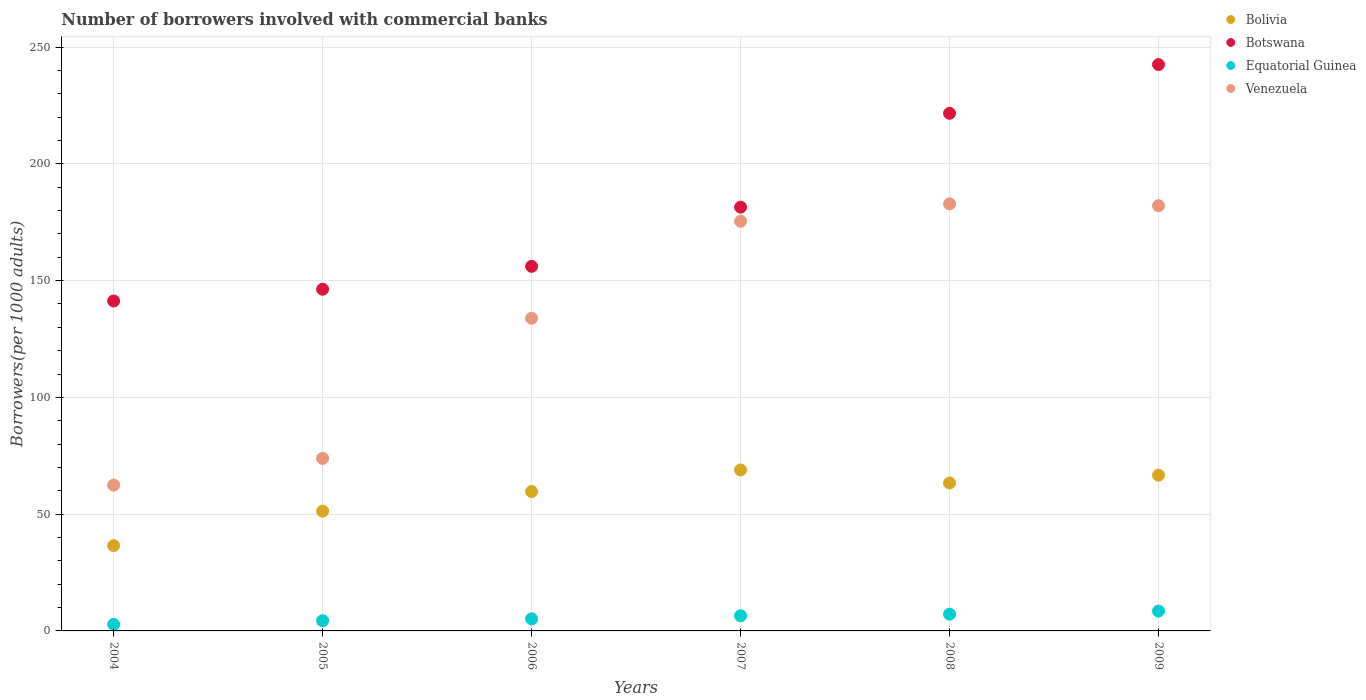How many different coloured dotlines are there?
Ensure brevity in your answer.  4. Is the number of dotlines equal to the number of legend labels?
Offer a terse response. Yes. What is the number of borrowers involved with commercial banks in Equatorial Guinea in 2006?
Keep it short and to the point. 5.18. Across all years, what is the maximum number of borrowers involved with commercial banks in Botswana?
Your answer should be compact. 242.52. Across all years, what is the minimum number of borrowers involved with commercial banks in Botswana?
Provide a short and direct response. 141.29. In which year was the number of borrowers involved with commercial banks in Bolivia maximum?
Make the answer very short. 2007. In which year was the number of borrowers involved with commercial banks in Bolivia minimum?
Keep it short and to the point. 2004. What is the total number of borrowers involved with commercial banks in Bolivia in the graph?
Ensure brevity in your answer.  346.5. What is the difference between the number of borrowers involved with commercial banks in Bolivia in 2008 and that in 2009?
Offer a terse response. -3.32. What is the difference between the number of borrowers involved with commercial banks in Botswana in 2005 and the number of borrowers involved with commercial banks in Venezuela in 2007?
Ensure brevity in your answer.  -29.11. What is the average number of borrowers involved with commercial banks in Equatorial Guinea per year?
Your answer should be very brief. 5.75. In the year 2005, what is the difference between the number of borrowers involved with commercial banks in Botswana and number of borrowers involved with commercial banks in Bolivia?
Your response must be concise. 95.02. In how many years, is the number of borrowers involved with commercial banks in Botswana greater than 170?
Your answer should be very brief. 3. What is the ratio of the number of borrowers involved with commercial banks in Bolivia in 2005 to that in 2008?
Provide a short and direct response. 0.81. Is the number of borrowers involved with commercial banks in Equatorial Guinea in 2006 less than that in 2009?
Ensure brevity in your answer.  Yes. What is the difference between the highest and the second highest number of borrowers involved with commercial banks in Equatorial Guinea?
Your answer should be compact. 1.31. What is the difference between the highest and the lowest number of borrowers involved with commercial banks in Equatorial Guinea?
Keep it short and to the point. 5.69. Does the number of borrowers involved with commercial banks in Venezuela monotonically increase over the years?
Keep it short and to the point. No. Is the number of borrowers involved with commercial banks in Botswana strictly greater than the number of borrowers involved with commercial banks in Venezuela over the years?
Give a very brief answer. Yes. Is the number of borrowers involved with commercial banks in Bolivia strictly less than the number of borrowers involved with commercial banks in Botswana over the years?
Your answer should be very brief. Yes. How many dotlines are there?
Give a very brief answer. 4. How many years are there in the graph?
Give a very brief answer. 6. Where does the legend appear in the graph?
Provide a short and direct response. Top right. What is the title of the graph?
Provide a succinct answer. Number of borrowers involved with commercial banks. What is the label or title of the X-axis?
Keep it short and to the point. Years. What is the label or title of the Y-axis?
Offer a very short reply. Borrowers(per 1000 adults). What is the Borrowers(per 1000 adults) of Bolivia in 2004?
Provide a short and direct response. 36.52. What is the Borrowers(per 1000 adults) in Botswana in 2004?
Keep it short and to the point. 141.29. What is the Borrowers(per 1000 adults) in Equatorial Guinea in 2004?
Your answer should be compact. 2.8. What is the Borrowers(per 1000 adults) in Venezuela in 2004?
Offer a terse response. 62.44. What is the Borrowers(per 1000 adults) of Bolivia in 2005?
Offer a very short reply. 51.3. What is the Borrowers(per 1000 adults) of Botswana in 2005?
Offer a terse response. 146.32. What is the Borrowers(per 1000 adults) of Equatorial Guinea in 2005?
Your answer should be very brief. 4.37. What is the Borrowers(per 1000 adults) of Venezuela in 2005?
Make the answer very short. 73.86. What is the Borrowers(per 1000 adults) of Bolivia in 2006?
Provide a short and direct response. 59.71. What is the Borrowers(per 1000 adults) in Botswana in 2006?
Provide a short and direct response. 156.11. What is the Borrowers(per 1000 adults) of Equatorial Guinea in 2006?
Your answer should be compact. 5.18. What is the Borrowers(per 1000 adults) in Venezuela in 2006?
Offer a very short reply. 133.89. What is the Borrowers(per 1000 adults) in Bolivia in 2007?
Offer a terse response. 68.94. What is the Borrowers(per 1000 adults) of Botswana in 2007?
Your response must be concise. 181.45. What is the Borrowers(per 1000 adults) in Equatorial Guinea in 2007?
Make the answer very short. 6.49. What is the Borrowers(per 1000 adults) of Venezuela in 2007?
Ensure brevity in your answer.  175.43. What is the Borrowers(per 1000 adults) in Bolivia in 2008?
Your response must be concise. 63.36. What is the Borrowers(per 1000 adults) of Botswana in 2008?
Your response must be concise. 221.65. What is the Borrowers(per 1000 adults) in Equatorial Guinea in 2008?
Provide a succinct answer. 7.17. What is the Borrowers(per 1000 adults) of Venezuela in 2008?
Offer a terse response. 182.89. What is the Borrowers(per 1000 adults) of Bolivia in 2009?
Your answer should be compact. 66.68. What is the Borrowers(per 1000 adults) of Botswana in 2009?
Offer a terse response. 242.52. What is the Borrowers(per 1000 adults) of Equatorial Guinea in 2009?
Ensure brevity in your answer.  8.49. What is the Borrowers(per 1000 adults) of Venezuela in 2009?
Make the answer very short. 182.09. Across all years, what is the maximum Borrowers(per 1000 adults) in Bolivia?
Ensure brevity in your answer.  68.94. Across all years, what is the maximum Borrowers(per 1000 adults) in Botswana?
Your answer should be very brief. 242.52. Across all years, what is the maximum Borrowers(per 1000 adults) of Equatorial Guinea?
Offer a terse response. 8.49. Across all years, what is the maximum Borrowers(per 1000 adults) of Venezuela?
Offer a very short reply. 182.89. Across all years, what is the minimum Borrowers(per 1000 adults) of Bolivia?
Make the answer very short. 36.52. Across all years, what is the minimum Borrowers(per 1000 adults) in Botswana?
Provide a short and direct response. 141.29. Across all years, what is the minimum Borrowers(per 1000 adults) of Equatorial Guinea?
Your answer should be very brief. 2.8. Across all years, what is the minimum Borrowers(per 1000 adults) of Venezuela?
Your response must be concise. 62.44. What is the total Borrowers(per 1000 adults) of Bolivia in the graph?
Offer a terse response. 346.5. What is the total Borrowers(per 1000 adults) of Botswana in the graph?
Ensure brevity in your answer.  1089.34. What is the total Borrowers(per 1000 adults) in Equatorial Guinea in the graph?
Give a very brief answer. 34.5. What is the total Borrowers(per 1000 adults) of Venezuela in the graph?
Offer a very short reply. 810.61. What is the difference between the Borrowers(per 1000 adults) in Bolivia in 2004 and that in 2005?
Offer a terse response. -14.78. What is the difference between the Borrowers(per 1000 adults) of Botswana in 2004 and that in 2005?
Your answer should be compact. -5.03. What is the difference between the Borrowers(per 1000 adults) of Equatorial Guinea in 2004 and that in 2005?
Give a very brief answer. -1.57. What is the difference between the Borrowers(per 1000 adults) of Venezuela in 2004 and that in 2005?
Your answer should be very brief. -11.42. What is the difference between the Borrowers(per 1000 adults) in Bolivia in 2004 and that in 2006?
Give a very brief answer. -23.19. What is the difference between the Borrowers(per 1000 adults) in Botswana in 2004 and that in 2006?
Offer a very short reply. -14.83. What is the difference between the Borrowers(per 1000 adults) in Equatorial Guinea in 2004 and that in 2006?
Your answer should be compact. -2.38. What is the difference between the Borrowers(per 1000 adults) in Venezuela in 2004 and that in 2006?
Provide a short and direct response. -71.45. What is the difference between the Borrowers(per 1000 adults) in Bolivia in 2004 and that in 2007?
Your response must be concise. -32.42. What is the difference between the Borrowers(per 1000 adults) in Botswana in 2004 and that in 2007?
Keep it short and to the point. -40.17. What is the difference between the Borrowers(per 1000 adults) of Equatorial Guinea in 2004 and that in 2007?
Ensure brevity in your answer.  -3.69. What is the difference between the Borrowers(per 1000 adults) in Venezuela in 2004 and that in 2007?
Provide a short and direct response. -112.99. What is the difference between the Borrowers(per 1000 adults) of Bolivia in 2004 and that in 2008?
Keep it short and to the point. -26.84. What is the difference between the Borrowers(per 1000 adults) in Botswana in 2004 and that in 2008?
Make the answer very short. -80.36. What is the difference between the Borrowers(per 1000 adults) of Equatorial Guinea in 2004 and that in 2008?
Your answer should be very brief. -4.37. What is the difference between the Borrowers(per 1000 adults) of Venezuela in 2004 and that in 2008?
Provide a succinct answer. -120.44. What is the difference between the Borrowers(per 1000 adults) of Bolivia in 2004 and that in 2009?
Your response must be concise. -30.16. What is the difference between the Borrowers(per 1000 adults) in Botswana in 2004 and that in 2009?
Ensure brevity in your answer.  -101.24. What is the difference between the Borrowers(per 1000 adults) of Equatorial Guinea in 2004 and that in 2009?
Offer a terse response. -5.69. What is the difference between the Borrowers(per 1000 adults) of Venezuela in 2004 and that in 2009?
Your response must be concise. -119.64. What is the difference between the Borrowers(per 1000 adults) in Bolivia in 2005 and that in 2006?
Keep it short and to the point. -8.41. What is the difference between the Borrowers(per 1000 adults) of Botswana in 2005 and that in 2006?
Offer a very short reply. -9.79. What is the difference between the Borrowers(per 1000 adults) of Equatorial Guinea in 2005 and that in 2006?
Make the answer very short. -0.81. What is the difference between the Borrowers(per 1000 adults) in Venezuela in 2005 and that in 2006?
Make the answer very short. -60.03. What is the difference between the Borrowers(per 1000 adults) in Bolivia in 2005 and that in 2007?
Make the answer very short. -17.64. What is the difference between the Borrowers(per 1000 adults) in Botswana in 2005 and that in 2007?
Make the answer very short. -35.13. What is the difference between the Borrowers(per 1000 adults) of Equatorial Guinea in 2005 and that in 2007?
Keep it short and to the point. -2.12. What is the difference between the Borrowers(per 1000 adults) in Venezuela in 2005 and that in 2007?
Give a very brief answer. -101.57. What is the difference between the Borrowers(per 1000 adults) of Bolivia in 2005 and that in 2008?
Give a very brief answer. -12.06. What is the difference between the Borrowers(per 1000 adults) of Botswana in 2005 and that in 2008?
Offer a terse response. -75.33. What is the difference between the Borrowers(per 1000 adults) in Equatorial Guinea in 2005 and that in 2008?
Keep it short and to the point. -2.81. What is the difference between the Borrowers(per 1000 adults) in Venezuela in 2005 and that in 2008?
Make the answer very short. -109.03. What is the difference between the Borrowers(per 1000 adults) of Bolivia in 2005 and that in 2009?
Ensure brevity in your answer.  -15.38. What is the difference between the Borrowers(per 1000 adults) in Botswana in 2005 and that in 2009?
Keep it short and to the point. -96.2. What is the difference between the Borrowers(per 1000 adults) in Equatorial Guinea in 2005 and that in 2009?
Ensure brevity in your answer.  -4.12. What is the difference between the Borrowers(per 1000 adults) of Venezuela in 2005 and that in 2009?
Give a very brief answer. -108.23. What is the difference between the Borrowers(per 1000 adults) of Bolivia in 2006 and that in 2007?
Your response must be concise. -9.22. What is the difference between the Borrowers(per 1000 adults) of Botswana in 2006 and that in 2007?
Your response must be concise. -25.34. What is the difference between the Borrowers(per 1000 adults) in Equatorial Guinea in 2006 and that in 2007?
Your answer should be compact. -1.31. What is the difference between the Borrowers(per 1000 adults) of Venezuela in 2006 and that in 2007?
Offer a terse response. -41.54. What is the difference between the Borrowers(per 1000 adults) in Bolivia in 2006 and that in 2008?
Ensure brevity in your answer.  -3.65. What is the difference between the Borrowers(per 1000 adults) of Botswana in 2006 and that in 2008?
Your answer should be compact. -65.54. What is the difference between the Borrowers(per 1000 adults) in Equatorial Guinea in 2006 and that in 2008?
Offer a very short reply. -2. What is the difference between the Borrowers(per 1000 adults) in Venezuela in 2006 and that in 2008?
Offer a very short reply. -48.99. What is the difference between the Borrowers(per 1000 adults) of Bolivia in 2006 and that in 2009?
Provide a short and direct response. -6.97. What is the difference between the Borrowers(per 1000 adults) in Botswana in 2006 and that in 2009?
Provide a short and direct response. -86.41. What is the difference between the Borrowers(per 1000 adults) of Equatorial Guinea in 2006 and that in 2009?
Provide a short and direct response. -3.31. What is the difference between the Borrowers(per 1000 adults) in Venezuela in 2006 and that in 2009?
Your response must be concise. -48.19. What is the difference between the Borrowers(per 1000 adults) of Bolivia in 2007 and that in 2008?
Offer a terse response. 5.58. What is the difference between the Borrowers(per 1000 adults) of Botswana in 2007 and that in 2008?
Give a very brief answer. -40.2. What is the difference between the Borrowers(per 1000 adults) in Equatorial Guinea in 2007 and that in 2008?
Provide a short and direct response. -0.69. What is the difference between the Borrowers(per 1000 adults) of Venezuela in 2007 and that in 2008?
Your response must be concise. -7.45. What is the difference between the Borrowers(per 1000 adults) of Bolivia in 2007 and that in 2009?
Make the answer very short. 2.26. What is the difference between the Borrowers(per 1000 adults) in Botswana in 2007 and that in 2009?
Offer a terse response. -61.07. What is the difference between the Borrowers(per 1000 adults) in Equatorial Guinea in 2007 and that in 2009?
Provide a succinct answer. -2. What is the difference between the Borrowers(per 1000 adults) of Venezuela in 2007 and that in 2009?
Give a very brief answer. -6.65. What is the difference between the Borrowers(per 1000 adults) in Bolivia in 2008 and that in 2009?
Make the answer very short. -3.32. What is the difference between the Borrowers(per 1000 adults) of Botswana in 2008 and that in 2009?
Provide a short and direct response. -20.87. What is the difference between the Borrowers(per 1000 adults) in Equatorial Guinea in 2008 and that in 2009?
Provide a succinct answer. -1.31. What is the difference between the Borrowers(per 1000 adults) in Venezuela in 2008 and that in 2009?
Offer a terse response. 0.8. What is the difference between the Borrowers(per 1000 adults) of Bolivia in 2004 and the Borrowers(per 1000 adults) of Botswana in 2005?
Keep it short and to the point. -109.8. What is the difference between the Borrowers(per 1000 adults) in Bolivia in 2004 and the Borrowers(per 1000 adults) in Equatorial Guinea in 2005?
Give a very brief answer. 32.15. What is the difference between the Borrowers(per 1000 adults) of Bolivia in 2004 and the Borrowers(per 1000 adults) of Venezuela in 2005?
Ensure brevity in your answer.  -37.34. What is the difference between the Borrowers(per 1000 adults) of Botswana in 2004 and the Borrowers(per 1000 adults) of Equatorial Guinea in 2005?
Your answer should be very brief. 136.92. What is the difference between the Borrowers(per 1000 adults) of Botswana in 2004 and the Borrowers(per 1000 adults) of Venezuela in 2005?
Your answer should be very brief. 67.42. What is the difference between the Borrowers(per 1000 adults) in Equatorial Guinea in 2004 and the Borrowers(per 1000 adults) in Venezuela in 2005?
Provide a short and direct response. -71.06. What is the difference between the Borrowers(per 1000 adults) of Bolivia in 2004 and the Borrowers(per 1000 adults) of Botswana in 2006?
Ensure brevity in your answer.  -119.59. What is the difference between the Borrowers(per 1000 adults) in Bolivia in 2004 and the Borrowers(per 1000 adults) in Equatorial Guinea in 2006?
Your answer should be compact. 31.34. What is the difference between the Borrowers(per 1000 adults) of Bolivia in 2004 and the Borrowers(per 1000 adults) of Venezuela in 2006?
Ensure brevity in your answer.  -97.38. What is the difference between the Borrowers(per 1000 adults) in Botswana in 2004 and the Borrowers(per 1000 adults) in Equatorial Guinea in 2006?
Keep it short and to the point. 136.11. What is the difference between the Borrowers(per 1000 adults) in Botswana in 2004 and the Borrowers(per 1000 adults) in Venezuela in 2006?
Provide a succinct answer. 7.39. What is the difference between the Borrowers(per 1000 adults) in Equatorial Guinea in 2004 and the Borrowers(per 1000 adults) in Venezuela in 2006?
Your answer should be very brief. -131.09. What is the difference between the Borrowers(per 1000 adults) of Bolivia in 2004 and the Borrowers(per 1000 adults) of Botswana in 2007?
Make the answer very short. -144.93. What is the difference between the Borrowers(per 1000 adults) of Bolivia in 2004 and the Borrowers(per 1000 adults) of Equatorial Guinea in 2007?
Offer a terse response. 30.03. What is the difference between the Borrowers(per 1000 adults) in Bolivia in 2004 and the Borrowers(per 1000 adults) in Venezuela in 2007?
Provide a succinct answer. -138.91. What is the difference between the Borrowers(per 1000 adults) in Botswana in 2004 and the Borrowers(per 1000 adults) in Equatorial Guinea in 2007?
Provide a succinct answer. 134.8. What is the difference between the Borrowers(per 1000 adults) of Botswana in 2004 and the Borrowers(per 1000 adults) of Venezuela in 2007?
Ensure brevity in your answer.  -34.15. What is the difference between the Borrowers(per 1000 adults) of Equatorial Guinea in 2004 and the Borrowers(per 1000 adults) of Venezuela in 2007?
Give a very brief answer. -172.63. What is the difference between the Borrowers(per 1000 adults) of Bolivia in 2004 and the Borrowers(per 1000 adults) of Botswana in 2008?
Your answer should be very brief. -185.13. What is the difference between the Borrowers(per 1000 adults) of Bolivia in 2004 and the Borrowers(per 1000 adults) of Equatorial Guinea in 2008?
Offer a very short reply. 29.34. What is the difference between the Borrowers(per 1000 adults) of Bolivia in 2004 and the Borrowers(per 1000 adults) of Venezuela in 2008?
Make the answer very short. -146.37. What is the difference between the Borrowers(per 1000 adults) of Botswana in 2004 and the Borrowers(per 1000 adults) of Equatorial Guinea in 2008?
Keep it short and to the point. 134.11. What is the difference between the Borrowers(per 1000 adults) in Botswana in 2004 and the Borrowers(per 1000 adults) in Venezuela in 2008?
Offer a terse response. -41.6. What is the difference between the Borrowers(per 1000 adults) in Equatorial Guinea in 2004 and the Borrowers(per 1000 adults) in Venezuela in 2008?
Provide a succinct answer. -180.09. What is the difference between the Borrowers(per 1000 adults) in Bolivia in 2004 and the Borrowers(per 1000 adults) in Botswana in 2009?
Make the answer very short. -206. What is the difference between the Borrowers(per 1000 adults) of Bolivia in 2004 and the Borrowers(per 1000 adults) of Equatorial Guinea in 2009?
Offer a terse response. 28.03. What is the difference between the Borrowers(per 1000 adults) in Bolivia in 2004 and the Borrowers(per 1000 adults) in Venezuela in 2009?
Provide a succinct answer. -145.57. What is the difference between the Borrowers(per 1000 adults) in Botswana in 2004 and the Borrowers(per 1000 adults) in Equatorial Guinea in 2009?
Offer a very short reply. 132.8. What is the difference between the Borrowers(per 1000 adults) of Botswana in 2004 and the Borrowers(per 1000 adults) of Venezuela in 2009?
Ensure brevity in your answer.  -40.8. What is the difference between the Borrowers(per 1000 adults) of Equatorial Guinea in 2004 and the Borrowers(per 1000 adults) of Venezuela in 2009?
Offer a terse response. -179.29. What is the difference between the Borrowers(per 1000 adults) of Bolivia in 2005 and the Borrowers(per 1000 adults) of Botswana in 2006?
Keep it short and to the point. -104.81. What is the difference between the Borrowers(per 1000 adults) of Bolivia in 2005 and the Borrowers(per 1000 adults) of Equatorial Guinea in 2006?
Provide a short and direct response. 46.12. What is the difference between the Borrowers(per 1000 adults) in Bolivia in 2005 and the Borrowers(per 1000 adults) in Venezuela in 2006?
Offer a terse response. -82.6. What is the difference between the Borrowers(per 1000 adults) of Botswana in 2005 and the Borrowers(per 1000 adults) of Equatorial Guinea in 2006?
Ensure brevity in your answer.  141.14. What is the difference between the Borrowers(per 1000 adults) in Botswana in 2005 and the Borrowers(per 1000 adults) in Venezuela in 2006?
Provide a short and direct response. 12.42. What is the difference between the Borrowers(per 1000 adults) in Equatorial Guinea in 2005 and the Borrowers(per 1000 adults) in Venezuela in 2006?
Provide a succinct answer. -129.53. What is the difference between the Borrowers(per 1000 adults) of Bolivia in 2005 and the Borrowers(per 1000 adults) of Botswana in 2007?
Offer a terse response. -130.15. What is the difference between the Borrowers(per 1000 adults) in Bolivia in 2005 and the Borrowers(per 1000 adults) in Equatorial Guinea in 2007?
Keep it short and to the point. 44.81. What is the difference between the Borrowers(per 1000 adults) of Bolivia in 2005 and the Borrowers(per 1000 adults) of Venezuela in 2007?
Ensure brevity in your answer.  -124.13. What is the difference between the Borrowers(per 1000 adults) in Botswana in 2005 and the Borrowers(per 1000 adults) in Equatorial Guinea in 2007?
Give a very brief answer. 139.83. What is the difference between the Borrowers(per 1000 adults) of Botswana in 2005 and the Borrowers(per 1000 adults) of Venezuela in 2007?
Offer a very short reply. -29.11. What is the difference between the Borrowers(per 1000 adults) of Equatorial Guinea in 2005 and the Borrowers(per 1000 adults) of Venezuela in 2007?
Your answer should be very brief. -171.07. What is the difference between the Borrowers(per 1000 adults) of Bolivia in 2005 and the Borrowers(per 1000 adults) of Botswana in 2008?
Your answer should be compact. -170.35. What is the difference between the Borrowers(per 1000 adults) in Bolivia in 2005 and the Borrowers(per 1000 adults) in Equatorial Guinea in 2008?
Give a very brief answer. 44.12. What is the difference between the Borrowers(per 1000 adults) in Bolivia in 2005 and the Borrowers(per 1000 adults) in Venezuela in 2008?
Provide a succinct answer. -131.59. What is the difference between the Borrowers(per 1000 adults) in Botswana in 2005 and the Borrowers(per 1000 adults) in Equatorial Guinea in 2008?
Your answer should be very brief. 139.14. What is the difference between the Borrowers(per 1000 adults) of Botswana in 2005 and the Borrowers(per 1000 adults) of Venezuela in 2008?
Your response must be concise. -36.57. What is the difference between the Borrowers(per 1000 adults) in Equatorial Guinea in 2005 and the Borrowers(per 1000 adults) in Venezuela in 2008?
Your answer should be compact. -178.52. What is the difference between the Borrowers(per 1000 adults) of Bolivia in 2005 and the Borrowers(per 1000 adults) of Botswana in 2009?
Keep it short and to the point. -191.22. What is the difference between the Borrowers(per 1000 adults) in Bolivia in 2005 and the Borrowers(per 1000 adults) in Equatorial Guinea in 2009?
Your answer should be very brief. 42.81. What is the difference between the Borrowers(per 1000 adults) of Bolivia in 2005 and the Borrowers(per 1000 adults) of Venezuela in 2009?
Your response must be concise. -130.79. What is the difference between the Borrowers(per 1000 adults) in Botswana in 2005 and the Borrowers(per 1000 adults) in Equatorial Guinea in 2009?
Give a very brief answer. 137.83. What is the difference between the Borrowers(per 1000 adults) of Botswana in 2005 and the Borrowers(per 1000 adults) of Venezuela in 2009?
Your answer should be very brief. -35.77. What is the difference between the Borrowers(per 1000 adults) in Equatorial Guinea in 2005 and the Borrowers(per 1000 adults) in Venezuela in 2009?
Provide a short and direct response. -177.72. What is the difference between the Borrowers(per 1000 adults) in Bolivia in 2006 and the Borrowers(per 1000 adults) in Botswana in 2007?
Your answer should be very brief. -121.74. What is the difference between the Borrowers(per 1000 adults) in Bolivia in 2006 and the Borrowers(per 1000 adults) in Equatorial Guinea in 2007?
Ensure brevity in your answer.  53.22. What is the difference between the Borrowers(per 1000 adults) of Bolivia in 2006 and the Borrowers(per 1000 adults) of Venezuela in 2007?
Provide a succinct answer. -115.72. What is the difference between the Borrowers(per 1000 adults) of Botswana in 2006 and the Borrowers(per 1000 adults) of Equatorial Guinea in 2007?
Offer a terse response. 149.62. What is the difference between the Borrowers(per 1000 adults) of Botswana in 2006 and the Borrowers(per 1000 adults) of Venezuela in 2007?
Your response must be concise. -19.32. What is the difference between the Borrowers(per 1000 adults) of Equatorial Guinea in 2006 and the Borrowers(per 1000 adults) of Venezuela in 2007?
Your response must be concise. -170.26. What is the difference between the Borrowers(per 1000 adults) of Bolivia in 2006 and the Borrowers(per 1000 adults) of Botswana in 2008?
Your answer should be compact. -161.94. What is the difference between the Borrowers(per 1000 adults) of Bolivia in 2006 and the Borrowers(per 1000 adults) of Equatorial Guinea in 2008?
Give a very brief answer. 52.54. What is the difference between the Borrowers(per 1000 adults) in Bolivia in 2006 and the Borrowers(per 1000 adults) in Venezuela in 2008?
Keep it short and to the point. -123.18. What is the difference between the Borrowers(per 1000 adults) in Botswana in 2006 and the Borrowers(per 1000 adults) in Equatorial Guinea in 2008?
Offer a terse response. 148.94. What is the difference between the Borrowers(per 1000 adults) of Botswana in 2006 and the Borrowers(per 1000 adults) of Venezuela in 2008?
Your answer should be compact. -26.78. What is the difference between the Borrowers(per 1000 adults) in Equatorial Guinea in 2006 and the Borrowers(per 1000 adults) in Venezuela in 2008?
Your answer should be very brief. -177.71. What is the difference between the Borrowers(per 1000 adults) in Bolivia in 2006 and the Borrowers(per 1000 adults) in Botswana in 2009?
Your answer should be compact. -182.81. What is the difference between the Borrowers(per 1000 adults) in Bolivia in 2006 and the Borrowers(per 1000 adults) in Equatorial Guinea in 2009?
Offer a very short reply. 51.22. What is the difference between the Borrowers(per 1000 adults) in Bolivia in 2006 and the Borrowers(per 1000 adults) in Venezuela in 2009?
Your answer should be very brief. -122.38. What is the difference between the Borrowers(per 1000 adults) of Botswana in 2006 and the Borrowers(per 1000 adults) of Equatorial Guinea in 2009?
Your answer should be compact. 147.62. What is the difference between the Borrowers(per 1000 adults) in Botswana in 2006 and the Borrowers(per 1000 adults) in Venezuela in 2009?
Your response must be concise. -25.98. What is the difference between the Borrowers(per 1000 adults) of Equatorial Guinea in 2006 and the Borrowers(per 1000 adults) of Venezuela in 2009?
Ensure brevity in your answer.  -176.91. What is the difference between the Borrowers(per 1000 adults) in Bolivia in 2007 and the Borrowers(per 1000 adults) in Botswana in 2008?
Offer a very short reply. -152.71. What is the difference between the Borrowers(per 1000 adults) of Bolivia in 2007 and the Borrowers(per 1000 adults) of Equatorial Guinea in 2008?
Give a very brief answer. 61.76. What is the difference between the Borrowers(per 1000 adults) in Bolivia in 2007 and the Borrowers(per 1000 adults) in Venezuela in 2008?
Give a very brief answer. -113.95. What is the difference between the Borrowers(per 1000 adults) of Botswana in 2007 and the Borrowers(per 1000 adults) of Equatorial Guinea in 2008?
Give a very brief answer. 174.28. What is the difference between the Borrowers(per 1000 adults) in Botswana in 2007 and the Borrowers(per 1000 adults) in Venezuela in 2008?
Your answer should be very brief. -1.43. What is the difference between the Borrowers(per 1000 adults) of Equatorial Guinea in 2007 and the Borrowers(per 1000 adults) of Venezuela in 2008?
Offer a very short reply. -176.4. What is the difference between the Borrowers(per 1000 adults) of Bolivia in 2007 and the Borrowers(per 1000 adults) of Botswana in 2009?
Your answer should be compact. -173.59. What is the difference between the Borrowers(per 1000 adults) of Bolivia in 2007 and the Borrowers(per 1000 adults) of Equatorial Guinea in 2009?
Give a very brief answer. 60.45. What is the difference between the Borrowers(per 1000 adults) of Bolivia in 2007 and the Borrowers(per 1000 adults) of Venezuela in 2009?
Provide a succinct answer. -113.15. What is the difference between the Borrowers(per 1000 adults) of Botswana in 2007 and the Borrowers(per 1000 adults) of Equatorial Guinea in 2009?
Keep it short and to the point. 172.96. What is the difference between the Borrowers(per 1000 adults) of Botswana in 2007 and the Borrowers(per 1000 adults) of Venezuela in 2009?
Your answer should be very brief. -0.63. What is the difference between the Borrowers(per 1000 adults) in Equatorial Guinea in 2007 and the Borrowers(per 1000 adults) in Venezuela in 2009?
Provide a short and direct response. -175.6. What is the difference between the Borrowers(per 1000 adults) in Bolivia in 2008 and the Borrowers(per 1000 adults) in Botswana in 2009?
Provide a short and direct response. -179.16. What is the difference between the Borrowers(per 1000 adults) of Bolivia in 2008 and the Borrowers(per 1000 adults) of Equatorial Guinea in 2009?
Provide a short and direct response. 54.87. What is the difference between the Borrowers(per 1000 adults) of Bolivia in 2008 and the Borrowers(per 1000 adults) of Venezuela in 2009?
Offer a terse response. -118.73. What is the difference between the Borrowers(per 1000 adults) of Botswana in 2008 and the Borrowers(per 1000 adults) of Equatorial Guinea in 2009?
Your response must be concise. 213.16. What is the difference between the Borrowers(per 1000 adults) in Botswana in 2008 and the Borrowers(per 1000 adults) in Venezuela in 2009?
Provide a short and direct response. 39.56. What is the difference between the Borrowers(per 1000 adults) in Equatorial Guinea in 2008 and the Borrowers(per 1000 adults) in Venezuela in 2009?
Your answer should be very brief. -174.91. What is the average Borrowers(per 1000 adults) of Bolivia per year?
Offer a terse response. 57.75. What is the average Borrowers(per 1000 adults) of Botswana per year?
Your answer should be compact. 181.56. What is the average Borrowers(per 1000 adults) in Equatorial Guinea per year?
Provide a short and direct response. 5.75. What is the average Borrowers(per 1000 adults) in Venezuela per year?
Your answer should be very brief. 135.1. In the year 2004, what is the difference between the Borrowers(per 1000 adults) of Bolivia and Borrowers(per 1000 adults) of Botswana?
Your answer should be very brief. -104.77. In the year 2004, what is the difference between the Borrowers(per 1000 adults) of Bolivia and Borrowers(per 1000 adults) of Equatorial Guinea?
Keep it short and to the point. 33.72. In the year 2004, what is the difference between the Borrowers(per 1000 adults) in Bolivia and Borrowers(per 1000 adults) in Venezuela?
Offer a very short reply. -25.93. In the year 2004, what is the difference between the Borrowers(per 1000 adults) in Botswana and Borrowers(per 1000 adults) in Equatorial Guinea?
Keep it short and to the point. 138.49. In the year 2004, what is the difference between the Borrowers(per 1000 adults) of Botswana and Borrowers(per 1000 adults) of Venezuela?
Offer a terse response. 78.84. In the year 2004, what is the difference between the Borrowers(per 1000 adults) of Equatorial Guinea and Borrowers(per 1000 adults) of Venezuela?
Give a very brief answer. -59.64. In the year 2005, what is the difference between the Borrowers(per 1000 adults) of Bolivia and Borrowers(per 1000 adults) of Botswana?
Give a very brief answer. -95.02. In the year 2005, what is the difference between the Borrowers(per 1000 adults) in Bolivia and Borrowers(per 1000 adults) in Equatorial Guinea?
Give a very brief answer. 46.93. In the year 2005, what is the difference between the Borrowers(per 1000 adults) of Bolivia and Borrowers(per 1000 adults) of Venezuela?
Keep it short and to the point. -22.56. In the year 2005, what is the difference between the Borrowers(per 1000 adults) in Botswana and Borrowers(per 1000 adults) in Equatorial Guinea?
Provide a short and direct response. 141.95. In the year 2005, what is the difference between the Borrowers(per 1000 adults) in Botswana and Borrowers(per 1000 adults) in Venezuela?
Your answer should be very brief. 72.46. In the year 2005, what is the difference between the Borrowers(per 1000 adults) of Equatorial Guinea and Borrowers(per 1000 adults) of Venezuela?
Your response must be concise. -69.49. In the year 2006, what is the difference between the Borrowers(per 1000 adults) in Bolivia and Borrowers(per 1000 adults) in Botswana?
Provide a short and direct response. -96.4. In the year 2006, what is the difference between the Borrowers(per 1000 adults) of Bolivia and Borrowers(per 1000 adults) of Equatorial Guinea?
Offer a terse response. 54.53. In the year 2006, what is the difference between the Borrowers(per 1000 adults) of Bolivia and Borrowers(per 1000 adults) of Venezuela?
Keep it short and to the point. -74.18. In the year 2006, what is the difference between the Borrowers(per 1000 adults) of Botswana and Borrowers(per 1000 adults) of Equatorial Guinea?
Keep it short and to the point. 150.94. In the year 2006, what is the difference between the Borrowers(per 1000 adults) in Botswana and Borrowers(per 1000 adults) in Venezuela?
Ensure brevity in your answer.  22.22. In the year 2006, what is the difference between the Borrowers(per 1000 adults) of Equatorial Guinea and Borrowers(per 1000 adults) of Venezuela?
Make the answer very short. -128.72. In the year 2007, what is the difference between the Borrowers(per 1000 adults) in Bolivia and Borrowers(per 1000 adults) in Botswana?
Offer a terse response. -112.52. In the year 2007, what is the difference between the Borrowers(per 1000 adults) of Bolivia and Borrowers(per 1000 adults) of Equatorial Guinea?
Offer a very short reply. 62.45. In the year 2007, what is the difference between the Borrowers(per 1000 adults) of Bolivia and Borrowers(per 1000 adults) of Venezuela?
Give a very brief answer. -106.5. In the year 2007, what is the difference between the Borrowers(per 1000 adults) in Botswana and Borrowers(per 1000 adults) in Equatorial Guinea?
Give a very brief answer. 174.96. In the year 2007, what is the difference between the Borrowers(per 1000 adults) of Botswana and Borrowers(per 1000 adults) of Venezuela?
Give a very brief answer. 6.02. In the year 2007, what is the difference between the Borrowers(per 1000 adults) of Equatorial Guinea and Borrowers(per 1000 adults) of Venezuela?
Your response must be concise. -168.94. In the year 2008, what is the difference between the Borrowers(per 1000 adults) in Bolivia and Borrowers(per 1000 adults) in Botswana?
Your response must be concise. -158.29. In the year 2008, what is the difference between the Borrowers(per 1000 adults) of Bolivia and Borrowers(per 1000 adults) of Equatorial Guinea?
Your answer should be very brief. 56.18. In the year 2008, what is the difference between the Borrowers(per 1000 adults) of Bolivia and Borrowers(per 1000 adults) of Venezuela?
Your response must be concise. -119.53. In the year 2008, what is the difference between the Borrowers(per 1000 adults) in Botswana and Borrowers(per 1000 adults) in Equatorial Guinea?
Your response must be concise. 214.48. In the year 2008, what is the difference between the Borrowers(per 1000 adults) in Botswana and Borrowers(per 1000 adults) in Venezuela?
Provide a short and direct response. 38.76. In the year 2008, what is the difference between the Borrowers(per 1000 adults) of Equatorial Guinea and Borrowers(per 1000 adults) of Venezuela?
Provide a succinct answer. -175.71. In the year 2009, what is the difference between the Borrowers(per 1000 adults) of Bolivia and Borrowers(per 1000 adults) of Botswana?
Ensure brevity in your answer.  -175.84. In the year 2009, what is the difference between the Borrowers(per 1000 adults) in Bolivia and Borrowers(per 1000 adults) in Equatorial Guinea?
Provide a short and direct response. 58.19. In the year 2009, what is the difference between the Borrowers(per 1000 adults) of Bolivia and Borrowers(per 1000 adults) of Venezuela?
Ensure brevity in your answer.  -115.41. In the year 2009, what is the difference between the Borrowers(per 1000 adults) in Botswana and Borrowers(per 1000 adults) in Equatorial Guinea?
Offer a terse response. 234.03. In the year 2009, what is the difference between the Borrowers(per 1000 adults) in Botswana and Borrowers(per 1000 adults) in Venezuela?
Your answer should be very brief. 60.44. In the year 2009, what is the difference between the Borrowers(per 1000 adults) in Equatorial Guinea and Borrowers(per 1000 adults) in Venezuela?
Provide a succinct answer. -173.6. What is the ratio of the Borrowers(per 1000 adults) in Bolivia in 2004 to that in 2005?
Make the answer very short. 0.71. What is the ratio of the Borrowers(per 1000 adults) of Botswana in 2004 to that in 2005?
Give a very brief answer. 0.97. What is the ratio of the Borrowers(per 1000 adults) of Equatorial Guinea in 2004 to that in 2005?
Keep it short and to the point. 0.64. What is the ratio of the Borrowers(per 1000 adults) in Venezuela in 2004 to that in 2005?
Your answer should be compact. 0.85. What is the ratio of the Borrowers(per 1000 adults) in Bolivia in 2004 to that in 2006?
Provide a short and direct response. 0.61. What is the ratio of the Borrowers(per 1000 adults) of Botswana in 2004 to that in 2006?
Your answer should be compact. 0.91. What is the ratio of the Borrowers(per 1000 adults) of Equatorial Guinea in 2004 to that in 2006?
Give a very brief answer. 0.54. What is the ratio of the Borrowers(per 1000 adults) in Venezuela in 2004 to that in 2006?
Your answer should be compact. 0.47. What is the ratio of the Borrowers(per 1000 adults) in Bolivia in 2004 to that in 2007?
Your answer should be compact. 0.53. What is the ratio of the Borrowers(per 1000 adults) in Botswana in 2004 to that in 2007?
Make the answer very short. 0.78. What is the ratio of the Borrowers(per 1000 adults) in Equatorial Guinea in 2004 to that in 2007?
Offer a very short reply. 0.43. What is the ratio of the Borrowers(per 1000 adults) of Venezuela in 2004 to that in 2007?
Provide a succinct answer. 0.36. What is the ratio of the Borrowers(per 1000 adults) in Bolivia in 2004 to that in 2008?
Your response must be concise. 0.58. What is the ratio of the Borrowers(per 1000 adults) in Botswana in 2004 to that in 2008?
Make the answer very short. 0.64. What is the ratio of the Borrowers(per 1000 adults) of Equatorial Guinea in 2004 to that in 2008?
Your answer should be compact. 0.39. What is the ratio of the Borrowers(per 1000 adults) of Venezuela in 2004 to that in 2008?
Provide a succinct answer. 0.34. What is the ratio of the Borrowers(per 1000 adults) of Bolivia in 2004 to that in 2009?
Make the answer very short. 0.55. What is the ratio of the Borrowers(per 1000 adults) in Botswana in 2004 to that in 2009?
Keep it short and to the point. 0.58. What is the ratio of the Borrowers(per 1000 adults) of Equatorial Guinea in 2004 to that in 2009?
Make the answer very short. 0.33. What is the ratio of the Borrowers(per 1000 adults) of Venezuela in 2004 to that in 2009?
Keep it short and to the point. 0.34. What is the ratio of the Borrowers(per 1000 adults) in Bolivia in 2005 to that in 2006?
Keep it short and to the point. 0.86. What is the ratio of the Borrowers(per 1000 adults) in Botswana in 2005 to that in 2006?
Your answer should be very brief. 0.94. What is the ratio of the Borrowers(per 1000 adults) of Equatorial Guinea in 2005 to that in 2006?
Provide a short and direct response. 0.84. What is the ratio of the Borrowers(per 1000 adults) of Venezuela in 2005 to that in 2006?
Offer a very short reply. 0.55. What is the ratio of the Borrowers(per 1000 adults) of Bolivia in 2005 to that in 2007?
Offer a very short reply. 0.74. What is the ratio of the Borrowers(per 1000 adults) of Botswana in 2005 to that in 2007?
Offer a very short reply. 0.81. What is the ratio of the Borrowers(per 1000 adults) in Equatorial Guinea in 2005 to that in 2007?
Make the answer very short. 0.67. What is the ratio of the Borrowers(per 1000 adults) in Venezuela in 2005 to that in 2007?
Your answer should be compact. 0.42. What is the ratio of the Borrowers(per 1000 adults) in Bolivia in 2005 to that in 2008?
Provide a succinct answer. 0.81. What is the ratio of the Borrowers(per 1000 adults) of Botswana in 2005 to that in 2008?
Provide a succinct answer. 0.66. What is the ratio of the Borrowers(per 1000 adults) in Equatorial Guinea in 2005 to that in 2008?
Your response must be concise. 0.61. What is the ratio of the Borrowers(per 1000 adults) in Venezuela in 2005 to that in 2008?
Keep it short and to the point. 0.4. What is the ratio of the Borrowers(per 1000 adults) in Bolivia in 2005 to that in 2009?
Provide a short and direct response. 0.77. What is the ratio of the Borrowers(per 1000 adults) in Botswana in 2005 to that in 2009?
Provide a succinct answer. 0.6. What is the ratio of the Borrowers(per 1000 adults) of Equatorial Guinea in 2005 to that in 2009?
Your answer should be compact. 0.51. What is the ratio of the Borrowers(per 1000 adults) in Venezuela in 2005 to that in 2009?
Make the answer very short. 0.41. What is the ratio of the Borrowers(per 1000 adults) of Bolivia in 2006 to that in 2007?
Give a very brief answer. 0.87. What is the ratio of the Borrowers(per 1000 adults) of Botswana in 2006 to that in 2007?
Your response must be concise. 0.86. What is the ratio of the Borrowers(per 1000 adults) of Equatorial Guinea in 2006 to that in 2007?
Provide a succinct answer. 0.8. What is the ratio of the Borrowers(per 1000 adults) in Venezuela in 2006 to that in 2007?
Give a very brief answer. 0.76. What is the ratio of the Borrowers(per 1000 adults) in Bolivia in 2006 to that in 2008?
Offer a very short reply. 0.94. What is the ratio of the Borrowers(per 1000 adults) of Botswana in 2006 to that in 2008?
Offer a very short reply. 0.7. What is the ratio of the Borrowers(per 1000 adults) in Equatorial Guinea in 2006 to that in 2008?
Keep it short and to the point. 0.72. What is the ratio of the Borrowers(per 1000 adults) in Venezuela in 2006 to that in 2008?
Ensure brevity in your answer.  0.73. What is the ratio of the Borrowers(per 1000 adults) of Bolivia in 2006 to that in 2009?
Provide a succinct answer. 0.9. What is the ratio of the Borrowers(per 1000 adults) in Botswana in 2006 to that in 2009?
Offer a terse response. 0.64. What is the ratio of the Borrowers(per 1000 adults) in Equatorial Guinea in 2006 to that in 2009?
Offer a very short reply. 0.61. What is the ratio of the Borrowers(per 1000 adults) of Venezuela in 2006 to that in 2009?
Make the answer very short. 0.74. What is the ratio of the Borrowers(per 1000 adults) of Bolivia in 2007 to that in 2008?
Make the answer very short. 1.09. What is the ratio of the Borrowers(per 1000 adults) in Botswana in 2007 to that in 2008?
Your response must be concise. 0.82. What is the ratio of the Borrowers(per 1000 adults) of Equatorial Guinea in 2007 to that in 2008?
Give a very brief answer. 0.9. What is the ratio of the Borrowers(per 1000 adults) of Venezuela in 2007 to that in 2008?
Offer a very short reply. 0.96. What is the ratio of the Borrowers(per 1000 adults) of Bolivia in 2007 to that in 2009?
Provide a succinct answer. 1.03. What is the ratio of the Borrowers(per 1000 adults) in Botswana in 2007 to that in 2009?
Make the answer very short. 0.75. What is the ratio of the Borrowers(per 1000 adults) of Equatorial Guinea in 2007 to that in 2009?
Offer a terse response. 0.76. What is the ratio of the Borrowers(per 1000 adults) of Venezuela in 2007 to that in 2009?
Offer a very short reply. 0.96. What is the ratio of the Borrowers(per 1000 adults) in Bolivia in 2008 to that in 2009?
Make the answer very short. 0.95. What is the ratio of the Borrowers(per 1000 adults) of Botswana in 2008 to that in 2009?
Your answer should be very brief. 0.91. What is the ratio of the Borrowers(per 1000 adults) in Equatorial Guinea in 2008 to that in 2009?
Your answer should be very brief. 0.85. What is the ratio of the Borrowers(per 1000 adults) in Venezuela in 2008 to that in 2009?
Make the answer very short. 1. What is the difference between the highest and the second highest Borrowers(per 1000 adults) of Bolivia?
Your response must be concise. 2.26. What is the difference between the highest and the second highest Borrowers(per 1000 adults) of Botswana?
Give a very brief answer. 20.87. What is the difference between the highest and the second highest Borrowers(per 1000 adults) in Equatorial Guinea?
Ensure brevity in your answer.  1.31. What is the difference between the highest and the second highest Borrowers(per 1000 adults) in Venezuela?
Keep it short and to the point. 0.8. What is the difference between the highest and the lowest Borrowers(per 1000 adults) in Bolivia?
Provide a succinct answer. 32.42. What is the difference between the highest and the lowest Borrowers(per 1000 adults) of Botswana?
Provide a short and direct response. 101.24. What is the difference between the highest and the lowest Borrowers(per 1000 adults) in Equatorial Guinea?
Give a very brief answer. 5.69. What is the difference between the highest and the lowest Borrowers(per 1000 adults) of Venezuela?
Your answer should be very brief. 120.44. 